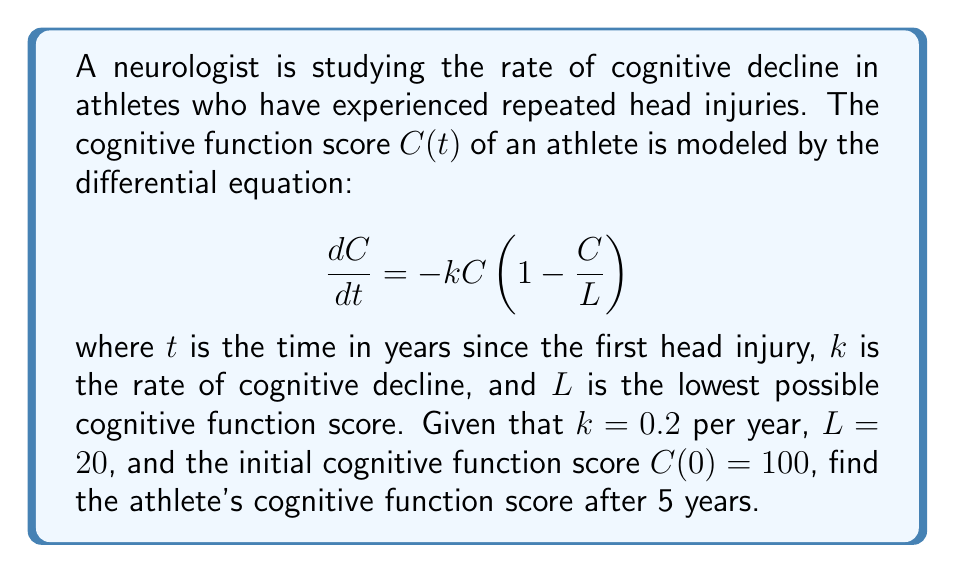Help me with this question. To solve this problem, we need to follow these steps:

1) First, we recognize this as a logistic differential equation in the form:

   $$\frac{dC}{dt} = -kC(1 - \frac{C}{L})$$

2) The solution to this equation is given by:

   $$C(t) = \frac{LC_0}{C_0 + (L-C_0)e^{kt}}$$

   where $C_0$ is the initial cognitive function score.

3) We are given the following values:
   - $k = 0.2$ per year
   - $L = 20$
   - $C_0 = C(0) = 100$
   - $t = 5$ years

4) Let's substitute these values into our solution:

   $$C(5) = \frac{20 \cdot 100}{100 + (20-100)e^{0.2 \cdot 5}}$$

5) Simplify:
   $$C(5) = \frac{2000}{100 - 80e^{1}}$$

6) Calculate $e^1 \approx 2.71828$:
   $$C(5) = \frac{2000}{100 - 80(2.71828)} \approx \frac{2000}{-117.4624}$$

7) Evaluate:
   $$C(5) \approx 17.03$$

Therefore, after 5 years, the athlete's cognitive function score will be approximately 17.03.
Answer: The athlete's cognitive function score after 5 years is approximately 17.03. 